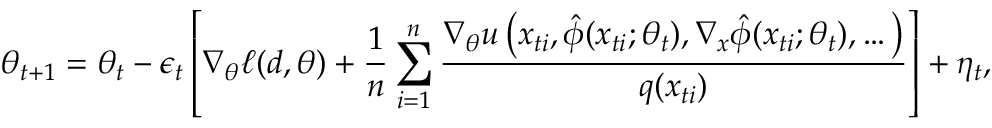<formula> <loc_0><loc_0><loc_500><loc_500>\theta _ { t + 1 } = \theta _ { t } - \epsilon _ { t } \left [ \nabla _ { \theta } \ell ( d , \theta ) + \frac { 1 } { n } \sum _ { i = 1 } ^ { n } \frac { \nabla _ { \theta } u \left ( x _ { t i } , \hat { \phi } ( x _ { t i } ; \theta _ { t } ) , \nabla _ { x } \hat { \phi } ( x _ { t i } ; \theta _ { t } ) , \dots \right ) } { q ( x _ { t i } ) } \right ] + \eta _ { t } ,</formula> 